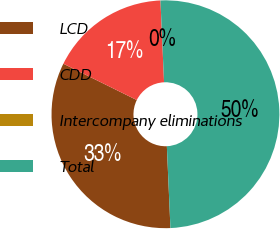<chart> <loc_0><loc_0><loc_500><loc_500><pie_chart><fcel>LCD<fcel>CDD<fcel>Intercompany eliminations<fcel>Total<nl><fcel>33.01%<fcel>16.99%<fcel>0.0%<fcel>50.0%<nl></chart> 